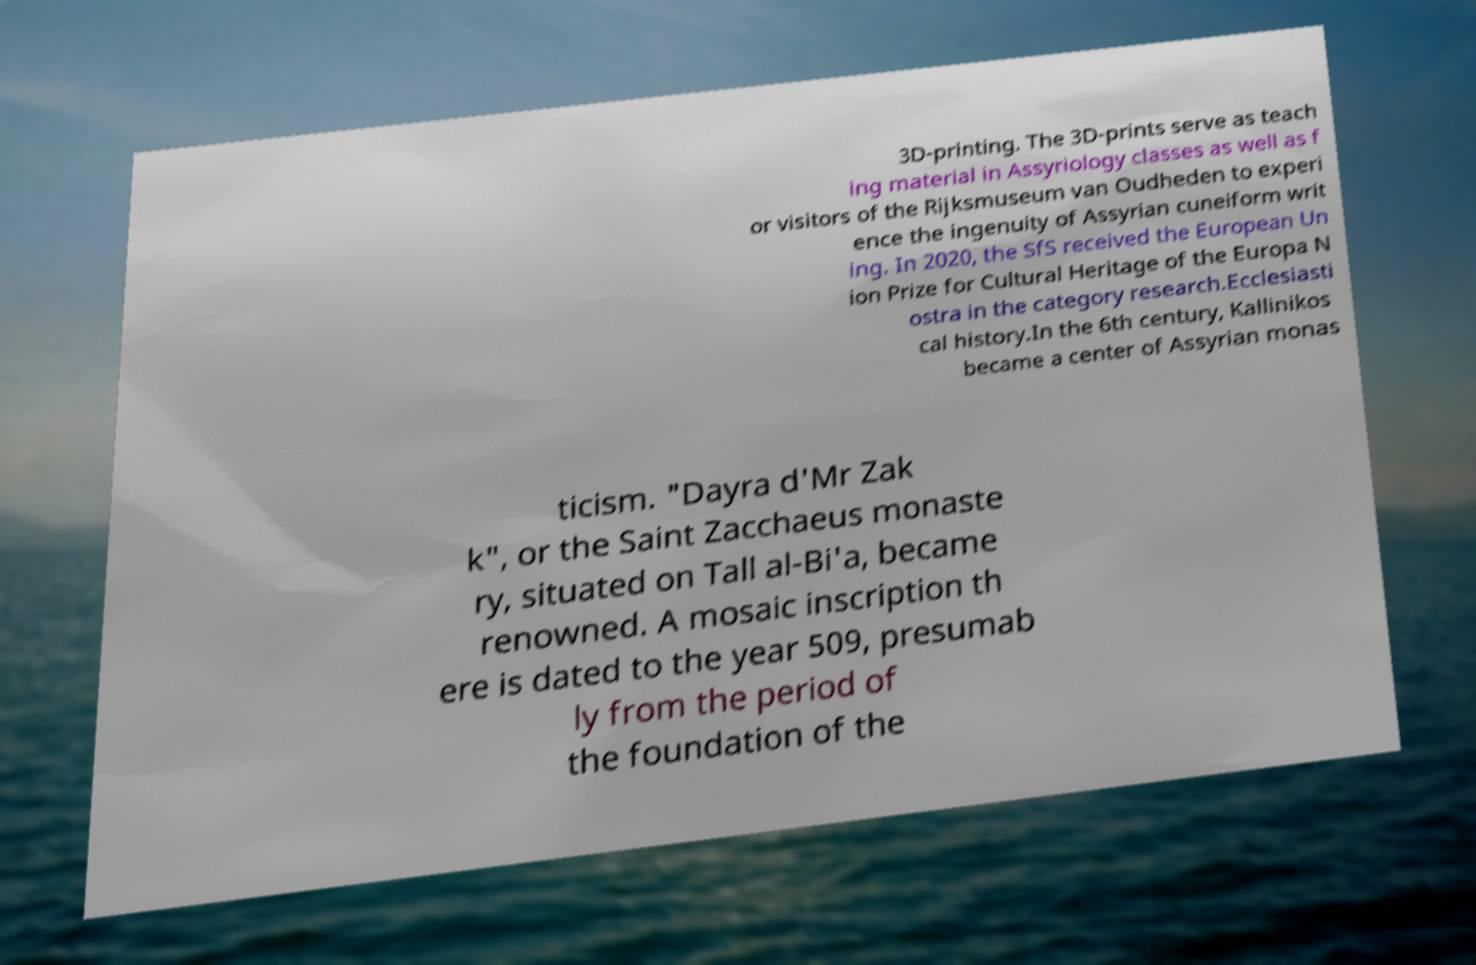What messages or text are displayed in this image? I need them in a readable, typed format. 3D-printing. The 3D-prints serve as teach ing material in Assyriology classes as well as f or visitors of the Rijksmuseum van Oudheden to experi ence the ingenuity of Assyrian cuneiform writ ing. In 2020, the SfS received the European Un ion Prize for Cultural Heritage of the Europa N ostra in the category research.Ecclesiasti cal history.In the 6th century, Kallinikos became a center of Assyrian monas ticism. "Dayra d'Mr Zak k", or the Saint Zacchaeus monaste ry, situated on Tall al-Bi'a, became renowned. A mosaic inscription th ere is dated to the year 509, presumab ly from the period of the foundation of the 